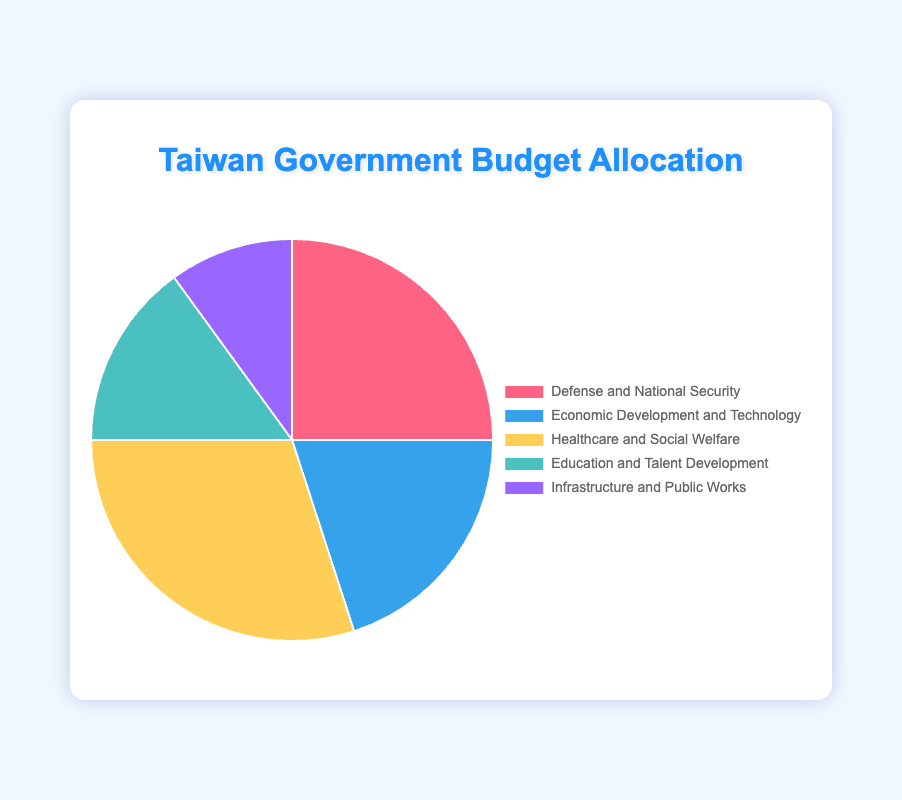What policy area receives the largest budget allocation? By referring to the pie chart, we can see which slice occupies the largest portion of the pie. The largest slice belongs to Healthcare and Social Welfare at 30%.
Answer: Healthcare and Social Welfare What is the combined budget allocation for Defense and National Security and Economic Development and Technology? Find the percentage for Defense and National Security (25%) and Economic Development and Technology (20%), then add them together: 25% + 20% = 45%.
Answer: 45% Which policy area has the least budget allocation and what is its percentage? Refer to the pie chart and identify the smallest slice. The smallest slice corresponds to Infrastructure and Public Works at 10%.
Answer: Infrastructure and Public Works, 10% How much greater is the allocation for Healthcare and Social Welfare compared to Infrastructure and Public Works? Subtract the percentage for Infrastructure and Public Works (10%) from Healthcare and Social Welfare (30%): 30% - 10% = 20%.
Answer: 20% Which two policy areas have a combined allocation equal to the allocation for Healthcare and Social Welfare? Look for two slices that sum up to the Healthcare and Social Welfare allocation (30%). Economic Development and Technology (20%) and Infrastructure and Public Works (10%) together sum up to 30%.
Answer: Economic Development and Technology, and Infrastructure and Public Works Is the budget allocation for Education and Talent Development less than the allocation for Defense and National Security? Compare the slices representing Education and Talent Development (15%) and Defense and National Security (25%). 15% is less than 25%.
Answer: Yes How does the budget allocation for Defense and National Security compare to the sum of allocations for Economic Development and Technology and Infrastructure and Public Works? Add up Economic Development and Technology (20%) and Infrastructure and Public Works (10%): 20% + 10% = 30%. Compare this with Defense and National Security (25%). 25% is less than 30%.
Answer: Less What is the difference in budget allocation between Education and Talent Development and Economic Development and Technology? Subtract the percentage for Education and Talent Development (15%) from Economic Development and Technology (20%): 20% - 15% = 5%.
Answer: 5% What percentage of the budget is allocated to non-defense policy areas? Non-defense areas are Economic Development and Technology (20%), Healthcare and Social Welfare (30%), Education and Talent Development (15%), and Infrastructure and Public Works (10%). Add these together: 20% + 30% + 15% + 10% = 75%.
Answer: 75% 